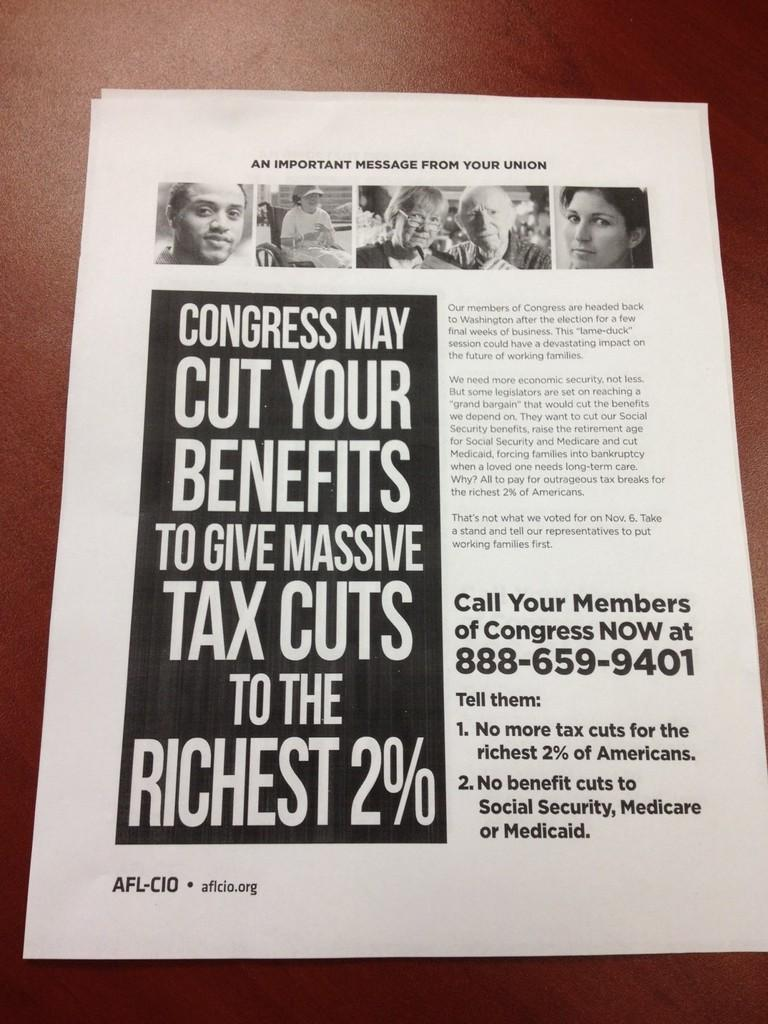<image>
Offer a succinct explanation of the picture presented. The pamphlet is claiming that congress may cut your benefits. 